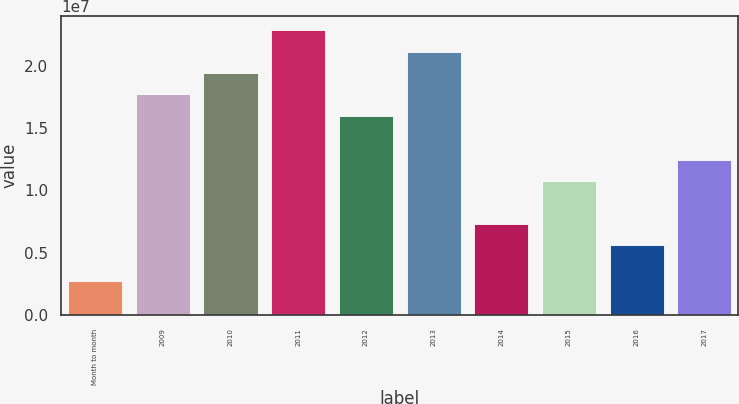Convert chart to OTSL. <chart><loc_0><loc_0><loc_500><loc_500><bar_chart><fcel>Month to month<fcel>2009<fcel>2010<fcel>2011<fcel>2012<fcel>2013<fcel>2014<fcel>2015<fcel>2016<fcel>2017<nl><fcel>2.758e+06<fcel>1.77173e+07<fcel>1.94326e+07<fcel>2.28632e+07<fcel>1.6002e+07<fcel>2.11479e+07<fcel>7.3013e+06<fcel>1.07319e+07<fcel>5.586e+06<fcel>1.24472e+07<nl></chart> 